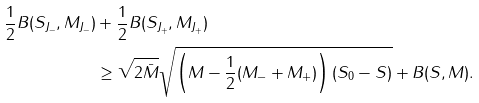<formula> <loc_0><loc_0><loc_500><loc_500>\frac { 1 } { 2 } B ( S _ { J _ { - } } , M _ { J _ { - } } ) & + \frac { 1 } { 2 } B ( S _ { J _ { + } } , M _ { J _ { + } } ) \\ & \geq \sqrt { 2 \bar { M } } \sqrt { \left ( M - \frac { 1 } { 2 } ( M _ { - } + M _ { + } ) \right ) ( S _ { 0 } - S ) } + B ( S , M ) .</formula> 